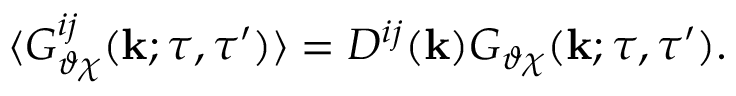Convert formula to latex. <formula><loc_0><loc_0><loc_500><loc_500>\langle { G _ { \vartheta \chi } ^ { i j } ( { k } ; \tau , \tau ^ { \prime } ) } \rangle = D ^ { i j } ( { k } ) G _ { \vartheta \chi } ( { k } ; \tau , \tau ^ { \prime } ) .</formula> 